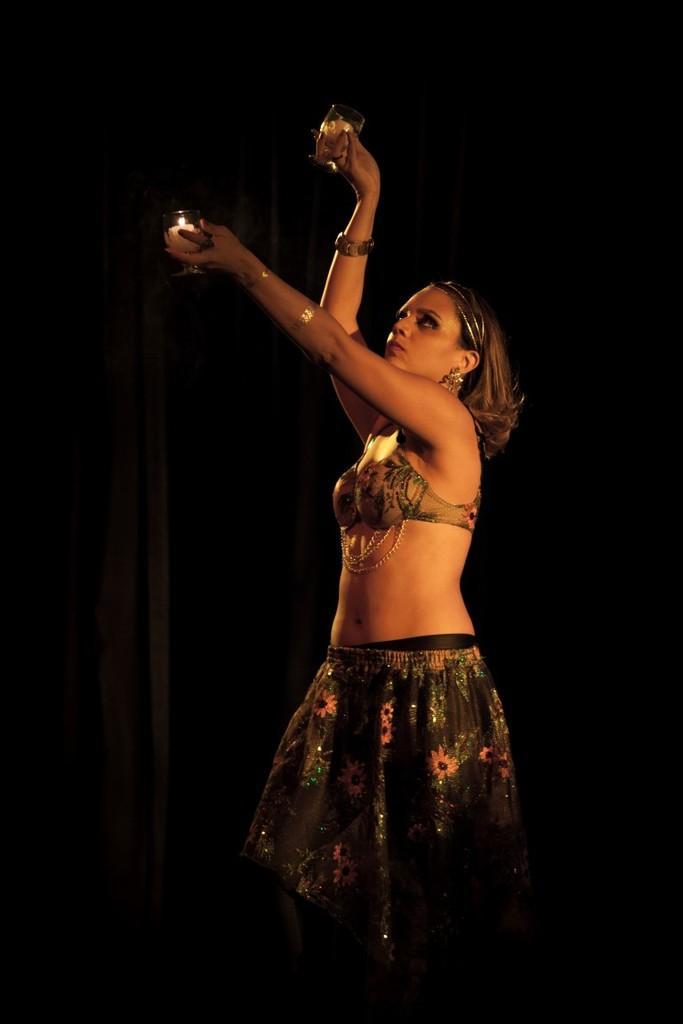Please provide a concise description of this image. In this image, we can see a woman standing and she is holding two glasses. 